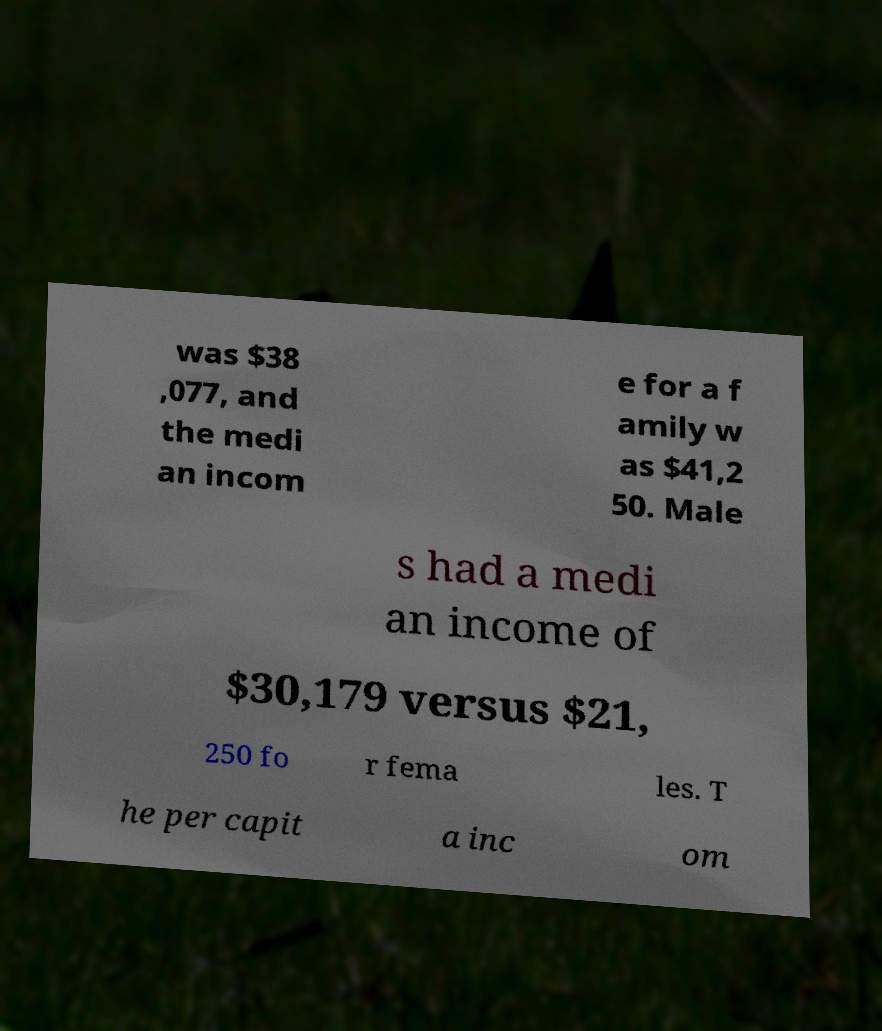For documentation purposes, I need the text within this image transcribed. Could you provide that? was $38 ,077, and the medi an incom e for a f amily w as $41,2 50. Male s had a medi an income of $30,179 versus $21, 250 fo r fema les. T he per capit a inc om 